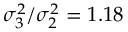Convert formula to latex. <formula><loc_0><loc_0><loc_500><loc_500>\sigma _ { 3 } ^ { 2 } / \sigma _ { 2 } ^ { 2 } = 1 . 1 8</formula> 